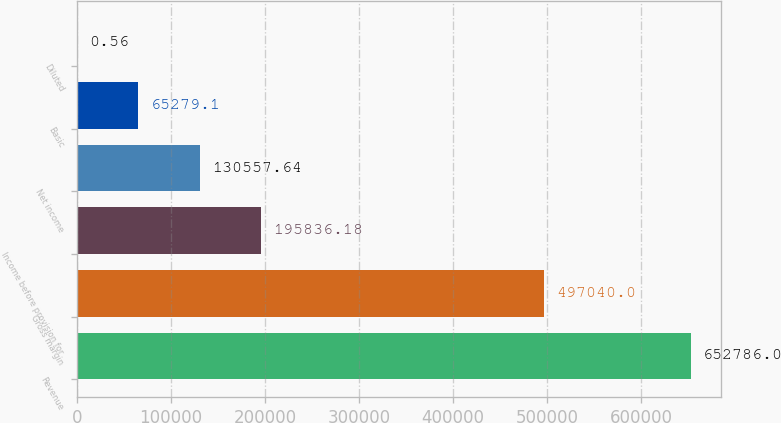Convert chart to OTSL. <chart><loc_0><loc_0><loc_500><loc_500><bar_chart><fcel>Revenue<fcel>Gross margin<fcel>Income before provision for<fcel>Net income<fcel>Basic<fcel>Diluted<nl><fcel>652786<fcel>497040<fcel>195836<fcel>130558<fcel>65279.1<fcel>0.56<nl></chart> 